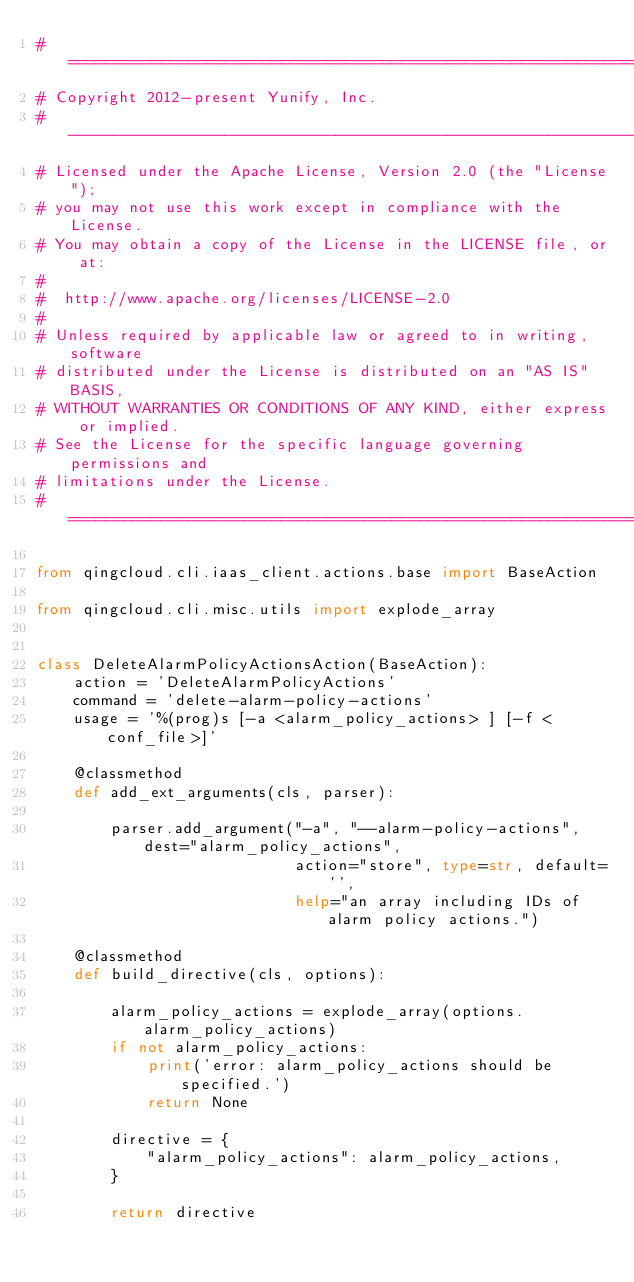Convert code to text. <code><loc_0><loc_0><loc_500><loc_500><_Python_># =========================================================================
# Copyright 2012-present Yunify, Inc.
# -------------------------------------------------------------------------
# Licensed under the Apache License, Version 2.0 (the "License");
# you may not use this work except in compliance with the License.
# You may obtain a copy of the License in the LICENSE file, or at:
#
#  http://www.apache.org/licenses/LICENSE-2.0
#
# Unless required by applicable law or agreed to in writing, software
# distributed under the License is distributed on an "AS IS" BASIS,
# WITHOUT WARRANTIES OR CONDITIONS OF ANY KIND, either express or implied.
# See the License for the specific language governing permissions and
# limitations under the License.
# =========================================================================

from qingcloud.cli.iaas_client.actions.base import BaseAction

from qingcloud.cli.misc.utils import explode_array


class DeleteAlarmPolicyActionsAction(BaseAction):
    action = 'DeleteAlarmPolicyActions'
    command = 'delete-alarm-policy-actions'
    usage = '%(prog)s [-a <alarm_policy_actions> ] [-f <conf_file>]'

    @classmethod
    def add_ext_arguments(cls, parser):

        parser.add_argument("-a", "--alarm-policy-actions", dest="alarm_policy_actions",
                            action="store", type=str, default='',
                            help="an array including IDs of alarm policy actions.")

    @classmethod
    def build_directive(cls, options):

        alarm_policy_actions = explode_array(options.alarm_policy_actions)
        if not alarm_policy_actions:
            print('error: alarm_policy_actions should be specified.')
            return None

        directive = {
            "alarm_policy_actions": alarm_policy_actions,
        }

        return directive
</code> 